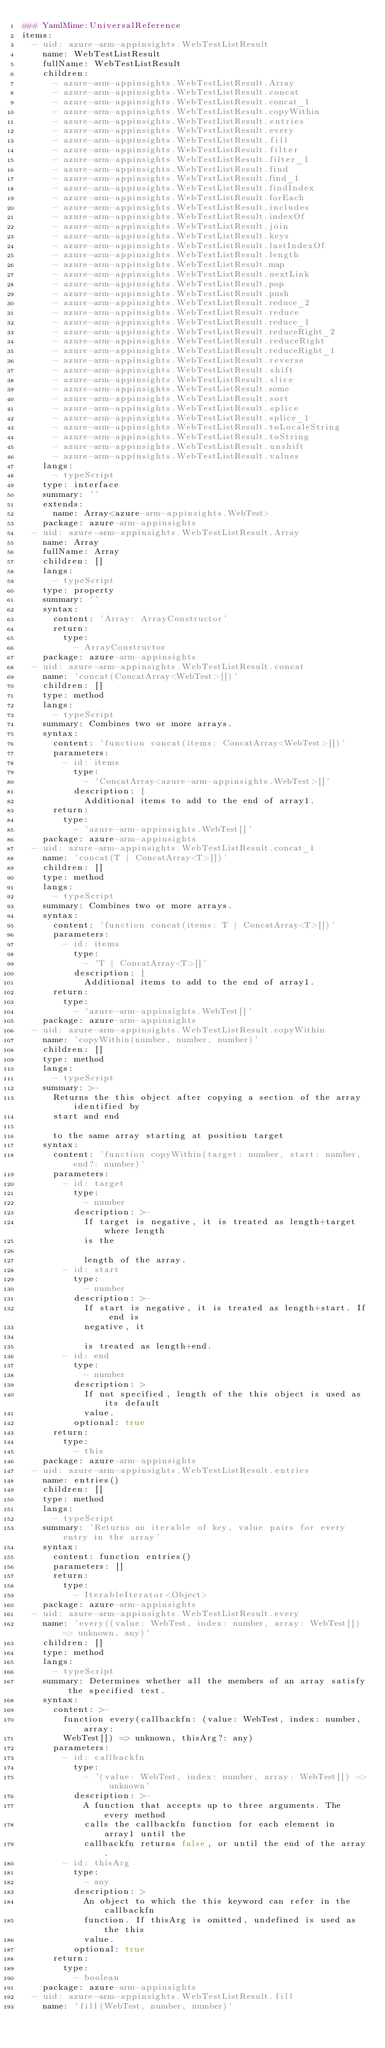Convert code to text. <code><loc_0><loc_0><loc_500><loc_500><_YAML_>### YamlMime:UniversalReference
items:
  - uid: azure-arm-appinsights.WebTestListResult
    name: WebTestListResult
    fullName: WebTestListResult
    children:
      - azure-arm-appinsights.WebTestListResult.Array
      - azure-arm-appinsights.WebTestListResult.concat
      - azure-arm-appinsights.WebTestListResult.concat_1
      - azure-arm-appinsights.WebTestListResult.copyWithin
      - azure-arm-appinsights.WebTestListResult.entries
      - azure-arm-appinsights.WebTestListResult.every
      - azure-arm-appinsights.WebTestListResult.fill
      - azure-arm-appinsights.WebTestListResult.filter
      - azure-arm-appinsights.WebTestListResult.filter_1
      - azure-arm-appinsights.WebTestListResult.find
      - azure-arm-appinsights.WebTestListResult.find_1
      - azure-arm-appinsights.WebTestListResult.findIndex
      - azure-arm-appinsights.WebTestListResult.forEach
      - azure-arm-appinsights.WebTestListResult.includes
      - azure-arm-appinsights.WebTestListResult.indexOf
      - azure-arm-appinsights.WebTestListResult.join
      - azure-arm-appinsights.WebTestListResult.keys
      - azure-arm-appinsights.WebTestListResult.lastIndexOf
      - azure-arm-appinsights.WebTestListResult.length
      - azure-arm-appinsights.WebTestListResult.map
      - azure-arm-appinsights.WebTestListResult.nextLink
      - azure-arm-appinsights.WebTestListResult.pop
      - azure-arm-appinsights.WebTestListResult.push
      - azure-arm-appinsights.WebTestListResult.reduce_2
      - azure-arm-appinsights.WebTestListResult.reduce
      - azure-arm-appinsights.WebTestListResult.reduce_1
      - azure-arm-appinsights.WebTestListResult.reduceRight_2
      - azure-arm-appinsights.WebTestListResult.reduceRight
      - azure-arm-appinsights.WebTestListResult.reduceRight_1
      - azure-arm-appinsights.WebTestListResult.reverse
      - azure-arm-appinsights.WebTestListResult.shift
      - azure-arm-appinsights.WebTestListResult.slice
      - azure-arm-appinsights.WebTestListResult.some
      - azure-arm-appinsights.WebTestListResult.sort
      - azure-arm-appinsights.WebTestListResult.splice
      - azure-arm-appinsights.WebTestListResult.splice_1
      - azure-arm-appinsights.WebTestListResult.toLocaleString
      - azure-arm-appinsights.WebTestListResult.toString
      - azure-arm-appinsights.WebTestListResult.unshift
      - azure-arm-appinsights.WebTestListResult.values
    langs:
      - typeScript
    type: interface
    summary: ''
    extends:
      name: Array<azure-arm-appinsights.WebTest>
    package: azure-arm-appinsights
  - uid: azure-arm-appinsights.WebTestListResult.Array
    name: Array
    fullName: Array
    children: []
    langs:
      - typeScript
    type: property
    summary: ''
    syntax:
      content: 'Array: ArrayConstructor'
      return:
        type:
          - ArrayConstructor
    package: azure-arm-appinsights
  - uid: azure-arm-appinsights.WebTestListResult.concat
    name: 'concat(ConcatArray<WebTest>[])'
    children: []
    type: method
    langs:
      - typeScript
    summary: Combines two or more arrays.
    syntax:
      content: 'function concat(items: ConcatArray<WebTest>[])'
      parameters:
        - id: items
          type:
            - 'ConcatArray<azure-arm-appinsights.WebTest>[]'
          description: |
            Additional items to add to the end of array1.
      return:
        type:
          - 'azure-arm-appinsights.WebTest[]'
    package: azure-arm-appinsights
  - uid: azure-arm-appinsights.WebTestListResult.concat_1
    name: 'concat(T | ConcatArray<T>[])'
    children: []
    type: method
    langs:
      - typeScript
    summary: Combines two or more arrays.
    syntax:
      content: 'function concat(items: T | ConcatArray<T>[])'
      parameters:
        - id: items
          type:
            - 'T | ConcatArray<T>[]'
          description: |
            Additional items to add to the end of array1.
      return:
        type:
          - 'azure-arm-appinsights.WebTest[]'
    package: azure-arm-appinsights
  - uid: azure-arm-appinsights.WebTestListResult.copyWithin
    name: 'copyWithin(number, number, number)'
    children: []
    type: method
    langs:
      - typeScript
    summary: >-
      Returns the this object after copying a section of the array identified by
      start and end

      to the same array starting at position target
    syntax:
      content: 'function copyWithin(target: number, start: number, end?: number)'
      parameters:
        - id: target
          type:
            - number
          description: >-
            If target is negative, it is treated as length+target where length
            is the

            length of the array.
        - id: start
          type:
            - number
          description: >-
            If start is negative, it is treated as length+start. If end is
            negative, it

            is treated as length+end.
        - id: end
          type:
            - number
          description: >
            If not specified, length of the this object is used as its default
            value.
          optional: true
      return:
        type:
          - this
    package: azure-arm-appinsights
  - uid: azure-arm-appinsights.WebTestListResult.entries
    name: entries()
    children: []
    type: method
    langs:
      - typeScript
    summary: 'Returns an iterable of key, value pairs for every entry in the array'
    syntax:
      content: function entries()
      parameters: []
      return:
        type:
          - IterableIterator<Object>
    package: azure-arm-appinsights
  - uid: azure-arm-appinsights.WebTestListResult.every
    name: 'every((value: WebTest, index: number, array: WebTest[]) => unknown, any)'
    children: []
    type: method
    langs:
      - typeScript
    summary: Determines whether all the members of an array satisfy the specified test.
    syntax:
      content: >-
        function every(callbackfn: (value: WebTest, index: number, array:
        WebTest[]) => unknown, thisArg?: any)
      parameters:
        - id: callbackfn
          type:
            - '(value: WebTest, index: number, array: WebTest[]) => unknown'
          description: >-
            A function that accepts up to three arguments. The every method
            calls the callbackfn function for each element in array1 until the
            callbackfn returns false, or until the end of the array.
        - id: thisArg
          type:
            - any
          description: >
            An object to which the this keyword can refer in the callbackfn
            function. If thisArg is omitted, undefined is used as the this
            value.
          optional: true
      return:
        type:
          - boolean
    package: azure-arm-appinsights
  - uid: azure-arm-appinsights.WebTestListResult.fill
    name: 'fill(WebTest, number, number)'</code> 